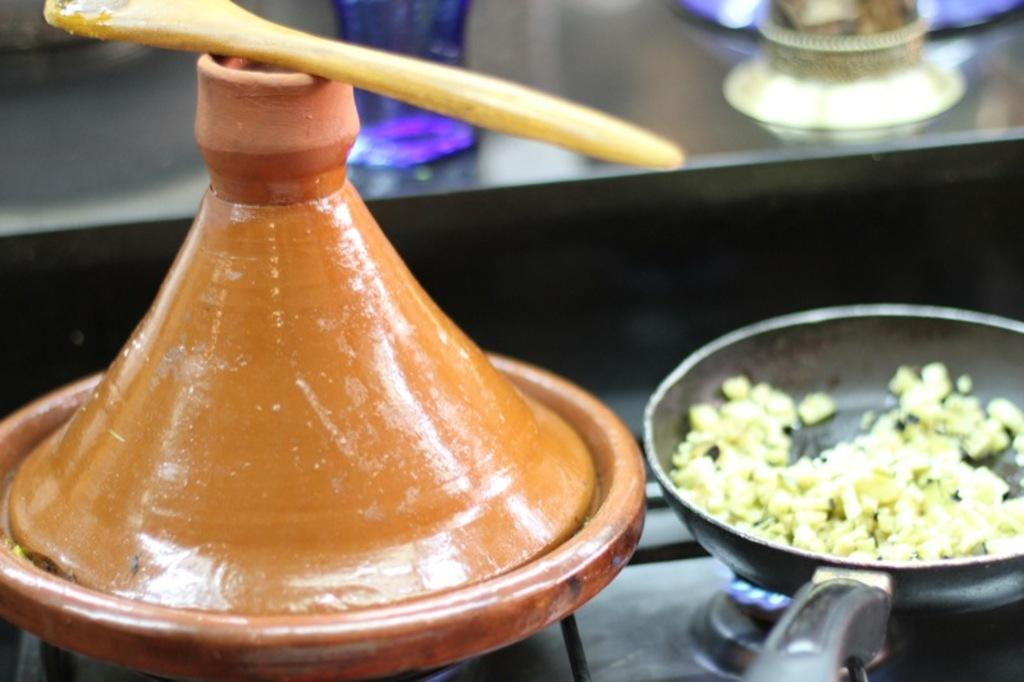What is being cooked in the skillet in the image? There is a food item in a skillet in the image, but the specific food cannot be determined from the facts provided. What is on the plate with a lid in the image? The facts do not specify what is on the plate with a lid. Where is the spoon located in the image? The spoon is on the stove in the image. What can be seen in the background of the image? There are objects visible in the background of the image, but the specific objects are not mentioned in the facts provided. What time is displayed on the clock in the image? There is no clock present in the image, so the time cannot be determined. What type of branch is hanging over the stove in the image? There is no branch present in the image; it is a kitchen setting with a stove, skillet, plate, and spoon. 